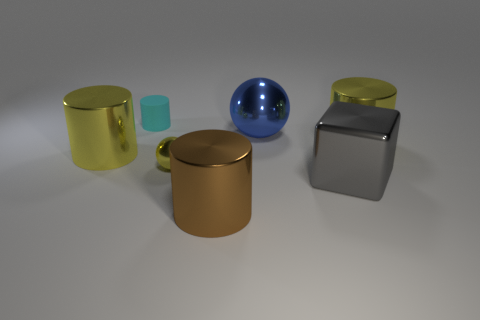Is there any other thing that is the same material as the tiny cylinder?
Keep it short and to the point. No. Is there a brown cylinder made of the same material as the gray cube?
Give a very brief answer. Yes. What number of things are tiny rubber objects or big yellow cylinders?
Your response must be concise. 3. Are the small yellow sphere and the big yellow thing to the right of the big brown object made of the same material?
Your response must be concise. Yes. There is a metal cylinder on the right side of the brown object; what size is it?
Your answer should be very brief. Large. Is the number of rubber cylinders less than the number of small things?
Ensure brevity in your answer.  Yes. Is there a metal cylinder of the same color as the tiny metallic ball?
Provide a succinct answer. Yes. There is a yellow thing that is to the left of the big gray metallic block and on the right side of the tiny cyan cylinder; what shape is it?
Give a very brief answer. Sphere. There is a big yellow metal object that is right of the big yellow shiny object on the left side of the big blue ball; what is its shape?
Your answer should be very brief. Cylinder. Is the shape of the blue metallic object the same as the gray shiny object?
Provide a succinct answer. No. 